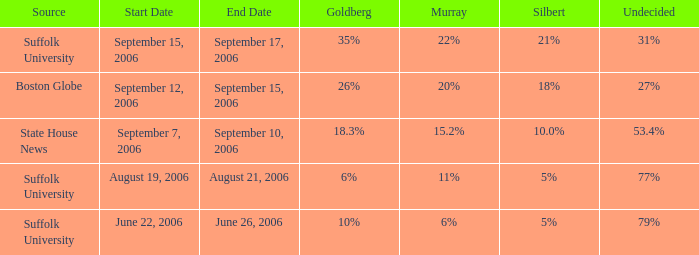What is the percentage of people who haven't made up their minds in the suffolk university poll that shows murray with an 11% support? 77%. Write the full table. {'header': ['Source', 'Start Date', 'End Date', 'Goldberg', 'Murray', 'Silbert', 'Undecided'], 'rows': [['Suffolk University', 'September 15, 2006', 'September 17, 2006', '35%', '22%', '21%', '31%'], ['Boston Globe', 'September 12, 2006', 'September 15, 2006', '26%', '20%', '18%', '27%'], ['State House News', 'September 7, 2006', 'September 10, 2006', '18.3%', '15.2%', '10.0%', '53.4%'], ['Suffolk University', 'August 19, 2006', 'August 21, 2006', '6%', '11%', '5%', '77%'], ['Suffolk University', 'June 22, 2006', 'June 26, 2006', '10%', '6%', '5%', '79%']]} 